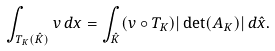Convert formula to latex. <formula><loc_0><loc_0><loc_500><loc_500>\int _ { T _ { K } ( \hat { K } ) } v \, d x = \int _ { \hat { K } } ( v \circ T _ { K } ) | \det ( A _ { K } ) | \, d \hat { x } .</formula> 